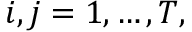Convert formula to latex. <formula><loc_0><loc_0><loc_500><loc_500>i , j = 1 , \dots , T ,</formula> 